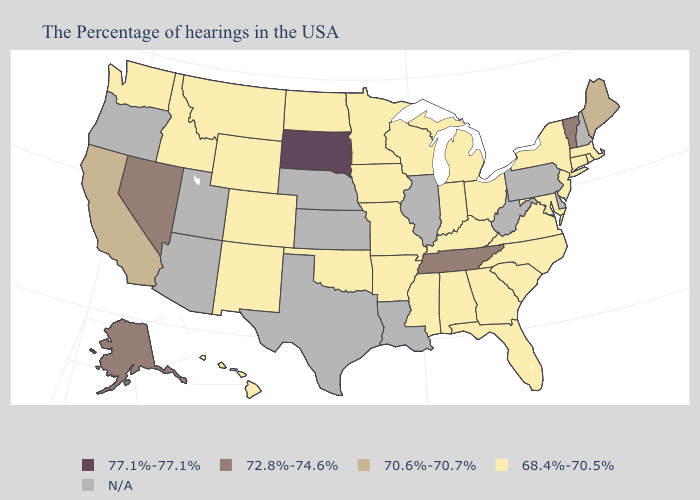Which states have the lowest value in the West?
Keep it brief. Wyoming, Colorado, New Mexico, Montana, Idaho, Washington, Hawaii. Name the states that have a value in the range 77.1%-77.1%?
Quick response, please. South Dakota. What is the value of Iowa?
Be succinct. 68.4%-70.5%. Which states have the highest value in the USA?
Keep it brief. South Dakota. How many symbols are there in the legend?
Concise answer only. 5. Which states have the lowest value in the Northeast?
Quick response, please. Massachusetts, Rhode Island, Connecticut, New York, New Jersey. Name the states that have a value in the range 70.6%-70.7%?
Keep it brief. Maine, California. Which states hav the highest value in the MidWest?
Be succinct. South Dakota. What is the value of Rhode Island?
Concise answer only. 68.4%-70.5%. What is the highest value in the Northeast ?
Answer briefly. 72.8%-74.6%. What is the value of California?
Keep it brief. 70.6%-70.7%. Name the states that have a value in the range 70.6%-70.7%?
Be succinct. Maine, California. What is the highest value in states that border South Dakota?
Write a very short answer. 68.4%-70.5%. Name the states that have a value in the range N/A?
Quick response, please. New Hampshire, Delaware, Pennsylvania, West Virginia, Illinois, Louisiana, Kansas, Nebraska, Texas, Utah, Arizona, Oregon. Which states hav the highest value in the West?
Short answer required. Nevada, Alaska. 